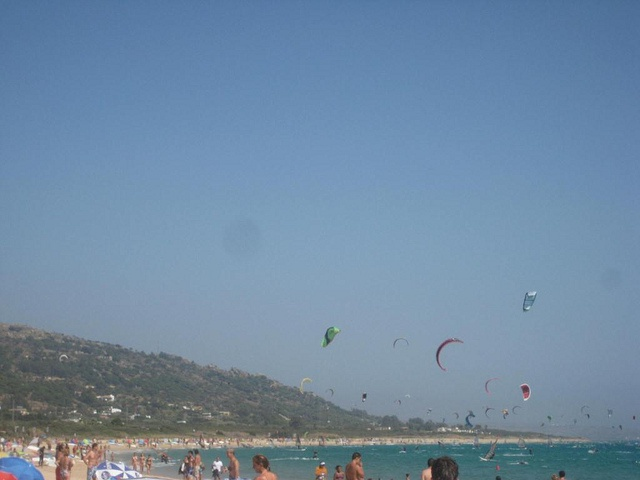Describe the objects in this image and their specific colors. I can see people in gray and darkgray tones, kite in gray tones, people in gray, brown, and darkgray tones, people in gray and black tones, and people in gray, brown, and maroon tones in this image. 